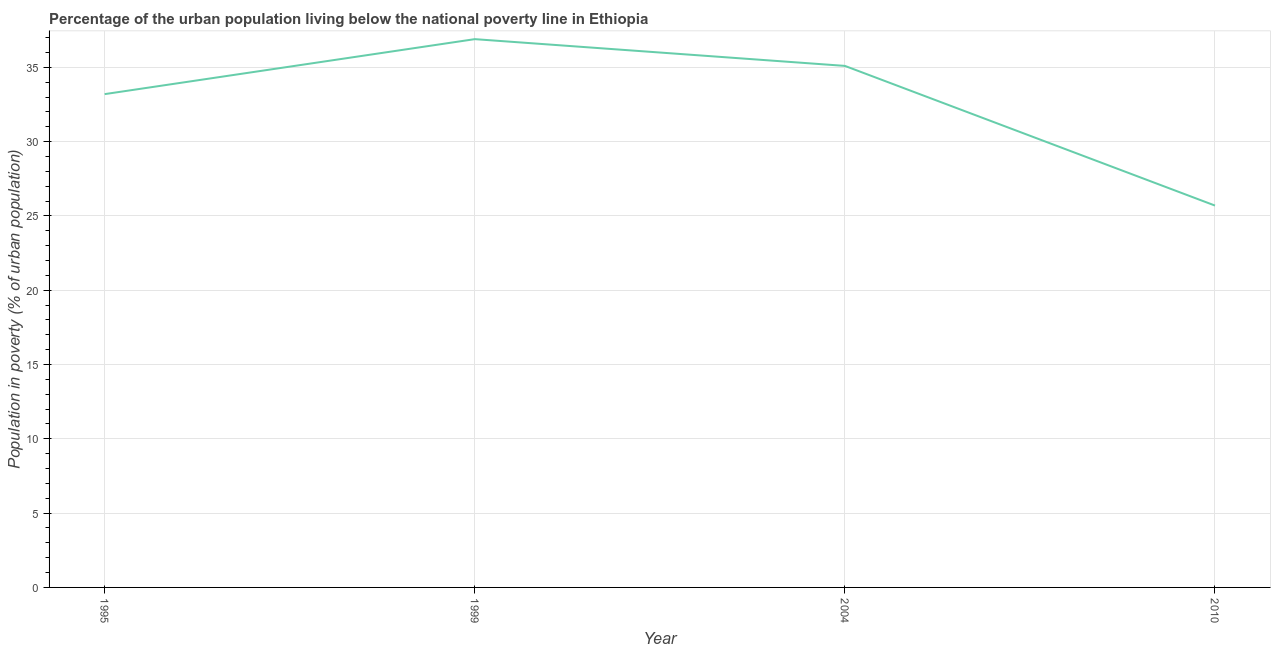What is the percentage of urban population living below poverty line in 1999?
Your answer should be very brief. 36.9. Across all years, what is the maximum percentage of urban population living below poverty line?
Offer a very short reply. 36.9. Across all years, what is the minimum percentage of urban population living below poverty line?
Provide a short and direct response. 25.7. What is the sum of the percentage of urban population living below poverty line?
Make the answer very short. 130.9. What is the difference between the percentage of urban population living below poverty line in 1995 and 2010?
Offer a terse response. 7.5. What is the average percentage of urban population living below poverty line per year?
Provide a short and direct response. 32.72. What is the median percentage of urban population living below poverty line?
Provide a short and direct response. 34.15. In how many years, is the percentage of urban population living below poverty line greater than 34 %?
Ensure brevity in your answer.  2. What is the ratio of the percentage of urban population living below poverty line in 1999 to that in 2004?
Provide a succinct answer. 1.05. What is the difference between the highest and the second highest percentage of urban population living below poverty line?
Offer a very short reply. 1.8. Is the sum of the percentage of urban population living below poverty line in 1999 and 2004 greater than the maximum percentage of urban population living below poverty line across all years?
Keep it short and to the point. Yes. What is the difference between the highest and the lowest percentage of urban population living below poverty line?
Make the answer very short. 11.2. How many lines are there?
Give a very brief answer. 1. What is the difference between two consecutive major ticks on the Y-axis?
Your answer should be very brief. 5. Does the graph contain grids?
Offer a very short reply. Yes. What is the title of the graph?
Provide a short and direct response. Percentage of the urban population living below the national poverty line in Ethiopia. What is the label or title of the X-axis?
Provide a short and direct response. Year. What is the label or title of the Y-axis?
Your answer should be very brief. Population in poverty (% of urban population). What is the Population in poverty (% of urban population) in 1995?
Give a very brief answer. 33.2. What is the Population in poverty (% of urban population) in 1999?
Make the answer very short. 36.9. What is the Population in poverty (% of urban population) of 2004?
Keep it short and to the point. 35.1. What is the Population in poverty (% of urban population) in 2010?
Give a very brief answer. 25.7. What is the difference between the Population in poverty (% of urban population) in 1995 and 1999?
Your answer should be compact. -3.7. What is the ratio of the Population in poverty (% of urban population) in 1995 to that in 1999?
Your answer should be compact. 0.9. What is the ratio of the Population in poverty (% of urban population) in 1995 to that in 2004?
Your response must be concise. 0.95. What is the ratio of the Population in poverty (% of urban population) in 1995 to that in 2010?
Your answer should be very brief. 1.29. What is the ratio of the Population in poverty (% of urban population) in 1999 to that in 2004?
Your response must be concise. 1.05. What is the ratio of the Population in poverty (% of urban population) in 1999 to that in 2010?
Offer a terse response. 1.44. What is the ratio of the Population in poverty (% of urban population) in 2004 to that in 2010?
Provide a short and direct response. 1.37. 